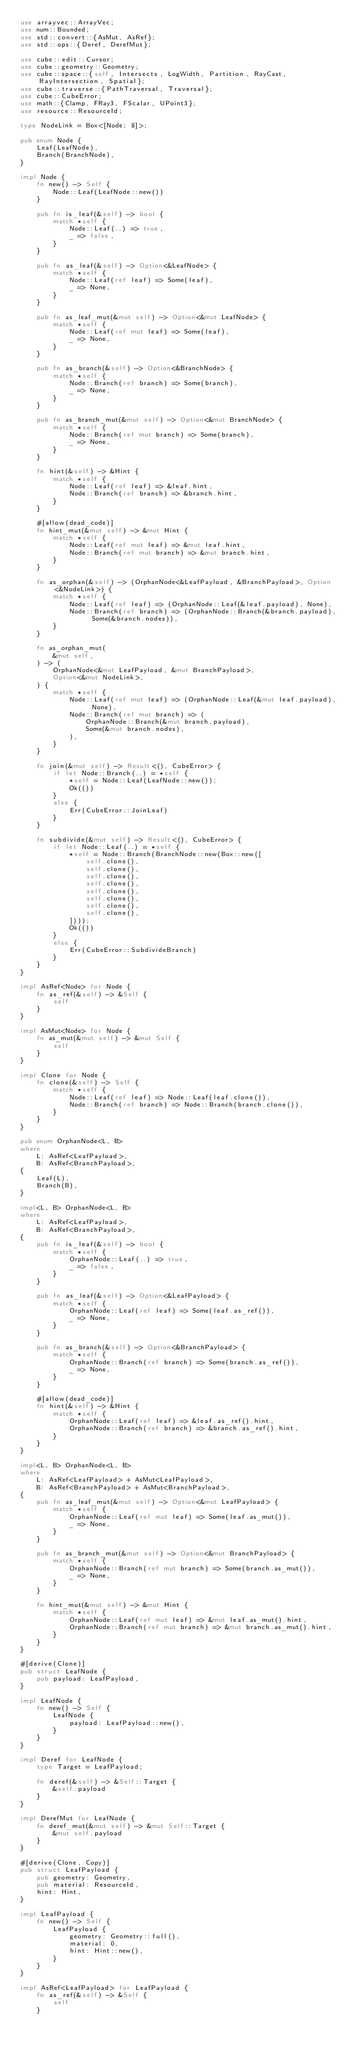Convert code to text. <code><loc_0><loc_0><loc_500><loc_500><_Rust_>use arrayvec::ArrayVec;
use num::Bounded;
use std::convert::{AsMut, AsRef};
use std::ops::{Deref, DerefMut};

use cube::edit::Cursor;
use cube::geometry::Geometry;
use cube::space::{self, Intersects, LogWidth, Partition, RayCast, RayIntersection, Spatial};
use cube::traverse::{PathTraversal, Traversal};
use cube::CubeError;
use math::{Clamp, FRay3, FScalar, UPoint3};
use resource::ResourceId;

type NodeLink = Box<[Node; 8]>;

pub enum Node {
    Leaf(LeafNode),
    Branch(BranchNode),
}

impl Node {
    fn new() -> Self {
        Node::Leaf(LeafNode::new())
    }

    pub fn is_leaf(&self) -> bool {
        match *self {
            Node::Leaf(..) => true,
            _ => false,
        }
    }

    pub fn as_leaf(&self) -> Option<&LeafNode> {
        match *self {
            Node::Leaf(ref leaf) => Some(leaf),
            _ => None,
        }
    }

    pub fn as_leaf_mut(&mut self) -> Option<&mut LeafNode> {
        match *self {
            Node::Leaf(ref mut leaf) => Some(leaf),
            _ => None,
        }
    }

    pub fn as_branch(&self) -> Option<&BranchNode> {
        match *self {
            Node::Branch(ref branch) => Some(branch),
            _ => None,
        }
    }

    pub fn as_branch_mut(&mut self) -> Option<&mut BranchNode> {
        match *self {
            Node::Branch(ref mut branch) => Some(branch),
            _ => None,
        }
    }

    fn hint(&self) -> &Hint {
        match *self {
            Node::Leaf(ref leaf) => &leaf.hint,
            Node::Branch(ref branch) => &branch.hint,
        }
    }

    #[allow(dead_code)]
    fn hint_mut(&mut self) -> &mut Hint {
        match *self {
            Node::Leaf(ref mut leaf) => &mut leaf.hint,
            Node::Branch(ref mut branch) => &mut branch.hint,
        }
    }

    fn as_orphan(&self) -> (OrphanNode<&LeafPayload, &BranchPayload>, Option<&NodeLink>) {
        match *self {
            Node::Leaf(ref leaf) => (OrphanNode::Leaf(&leaf.payload), None),
            Node::Branch(ref branch) => (OrphanNode::Branch(&branch.payload), Some(&branch.nodes)),
        }
    }

    fn as_orphan_mut(
        &mut self,
    ) -> (
        OrphanNode<&mut LeafPayload, &mut BranchPayload>,
        Option<&mut NodeLink>,
    ) {
        match *self {
            Node::Leaf(ref mut leaf) => (OrphanNode::Leaf(&mut leaf.payload), None),
            Node::Branch(ref mut branch) => (
                OrphanNode::Branch(&mut branch.payload),
                Some(&mut branch.nodes),
            ),
        }
    }

    fn join(&mut self) -> Result<(), CubeError> {
        if let Node::Branch(..) = *self {
            *self = Node::Leaf(LeafNode::new());
            Ok(())
        }
        else {
            Err(CubeError::JoinLeaf)
        }
    }

    fn subdivide(&mut self) -> Result<(), CubeError> {
        if let Node::Leaf(..) = *self {
            *self = Node::Branch(BranchNode::new(Box::new([
                self.clone(),
                self.clone(),
                self.clone(),
                self.clone(),
                self.clone(),
                self.clone(),
                self.clone(),
                self.clone(),
            ])));
            Ok(())
        }
        else {
            Err(CubeError::SubdivideBranch)
        }
    }
}

impl AsRef<Node> for Node {
    fn as_ref(&self) -> &Self {
        self
    }
}

impl AsMut<Node> for Node {
    fn as_mut(&mut self) -> &mut Self {
        self
    }
}

impl Clone for Node {
    fn clone(&self) -> Self {
        match *self {
            Node::Leaf(ref leaf) => Node::Leaf(leaf.clone()),
            Node::Branch(ref branch) => Node::Branch(branch.clone()),
        }
    }
}

pub enum OrphanNode<L, B>
where
    L: AsRef<LeafPayload>,
    B: AsRef<BranchPayload>,
{
    Leaf(L),
    Branch(B),
}

impl<L, B> OrphanNode<L, B>
where
    L: AsRef<LeafPayload>,
    B: AsRef<BranchPayload>,
{
    pub fn is_leaf(&self) -> bool {
        match *self {
            OrphanNode::Leaf(..) => true,
            _ => false,
        }
    }

    pub fn as_leaf(&self) -> Option<&LeafPayload> {
        match *self {
            OrphanNode::Leaf(ref leaf) => Some(leaf.as_ref()),
            _ => None,
        }
    }

    pub fn as_branch(&self) -> Option<&BranchPayload> {
        match *self {
            OrphanNode::Branch(ref branch) => Some(branch.as_ref()),
            _ => None,
        }
    }

    #[allow(dead_code)]
    fn hint(&self) -> &Hint {
        match *self {
            OrphanNode::Leaf(ref leaf) => &leaf.as_ref().hint,
            OrphanNode::Branch(ref branch) => &branch.as_ref().hint,
        }
    }
}

impl<L, B> OrphanNode<L, B>
where
    L: AsRef<LeafPayload> + AsMut<LeafPayload>,
    B: AsRef<BranchPayload> + AsMut<BranchPayload>,
{
    pub fn as_leaf_mut(&mut self) -> Option<&mut LeafPayload> {
        match *self {
            OrphanNode::Leaf(ref mut leaf) => Some(leaf.as_mut()),
            _ => None,
        }
    }

    pub fn as_branch_mut(&mut self) -> Option<&mut BranchPayload> {
        match *self {
            OrphanNode::Branch(ref mut branch) => Some(branch.as_mut()),
            _ => None,
        }
    }

    fn hint_mut(&mut self) -> &mut Hint {
        match *self {
            OrphanNode::Leaf(ref mut leaf) => &mut leaf.as_mut().hint,
            OrphanNode::Branch(ref mut branch) => &mut branch.as_mut().hint,
        }
    }
}

#[derive(Clone)]
pub struct LeafNode {
    pub payload: LeafPayload,
}

impl LeafNode {
    fn new() -> Self {
        LeafNode {
            payload: LeafPayload::new(),
        }
    }
}

impl Deref for LeafNode {
    type Target = LeafPayload;

    fn deref(&self) -> &Self::Target {
        &self.payload
    }
}

impl DerefMut for LeafNode {
    fn deref_mut(&mut self) -> &mut Self::Target {
        &mut self.payload
    }
}

#[derive(Clone, Copy)]
pub struct LeafPayload {
    pub geometry: Geometry,
    pub material: ResourceId,
    hint: Hint,
}

impl LeafPayload {
    fn new() -> Self {
        LeafPayload {
            geometry: Geometry::full(),
            material: 0,
            hint: Hint::new(),
        }
    }
}

impl AsRef<LeafPayload> for LeafPayload {
    fn as_ref(&self) -> &Self {
        self
    }</code> 